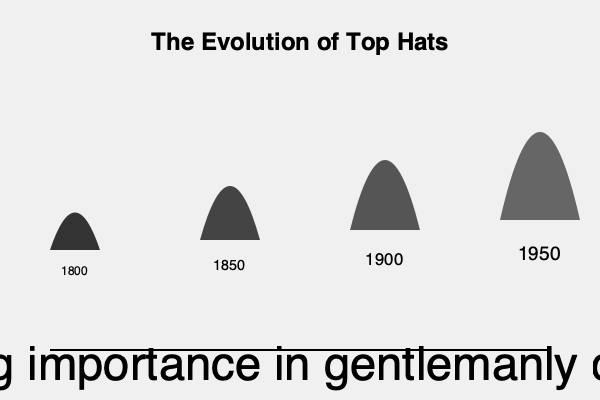Pray tell, dear reader, what sartorial evolution doth this infographic portray, and how might one interpret its correlation to the refinement of gentlemanly deportment? 1. Observe the chronological progression of top hats from left to right, spanning the years 1800 to 1950.

2. Note the gradual increase in hat height:
   - 1800: Shortest hat, resembling a squat beaver-pelt creation
   - 1850: Slightly taller, hinting at the burgeoning Industrial Revolution's influence
   - 1900: Considerably more elongated, mirroring the grandeur of the Victorian era
   - 1950: Tallest iteration, symbolizing the pinnacle of gentlemanly refinement

3. Examine the darkening shades of the hats, from a lighter grey in 1800 to a near-black in 1950, suggesting increased formality and sophistication.

4. Observe the text at the bottom, indicating a correlation between hat evolution and gentlemanly conduct.

5. Interpret this correlation:
   - As hats grew taller and darker, they became more associated with formal occasions and upper-class society.
   - The increasing height of the hat may symbolize the growing importance of etiquette and social graces in gentlemanly behavior.
   - The evolution of the top hat mirrors the refinement of societal norms and expectations for gentlemen during this period.

6. Conclude that the infographic suggests a parallel between the physical evolution of top hats and the increasing emphasis on gentlemanly conduct in society from 1800 to 1950.
Answer: Top hat height increase correlates with gentlemanly refinement (1800-1950). 